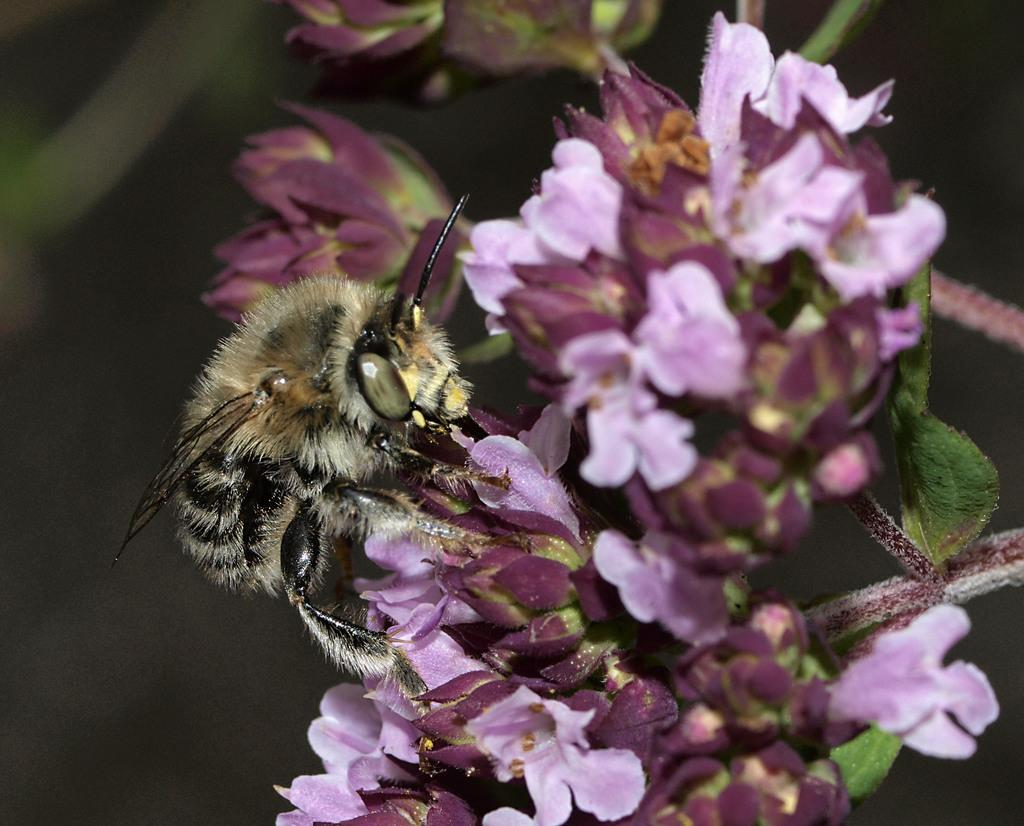What type of creature is present in the image? There is an insect in the image. What is the insect doing in the image? The insect is on brinjal-colored flowers. What can be seen on the right side of the image? There are green leaves on the right side of the image. In which direction is the ladybug facing in the image? There is no ladybug present in the image, only an insect on brinjal-colored flowers. Can you describe the romantic interaction between the insect and the flowers in the image? The image does not depict a romantic interaction between the insect and the flowers; it simply shows the insect on the flowers. 